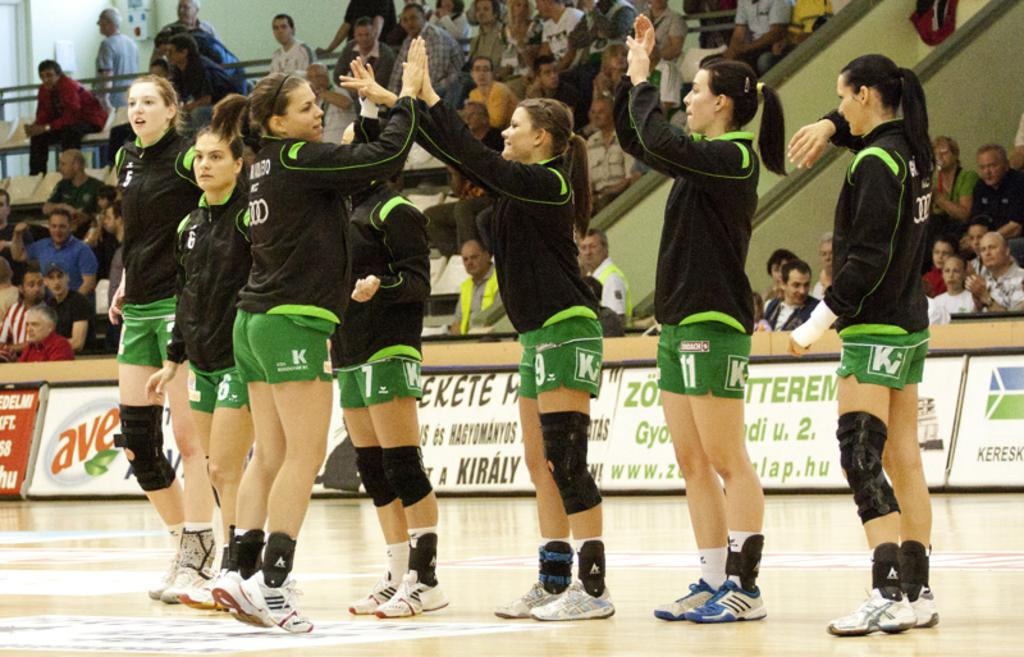<image>
Create a compact narrative representing the image presented. A girls volleyball team wearing green shorts with Ki on them 